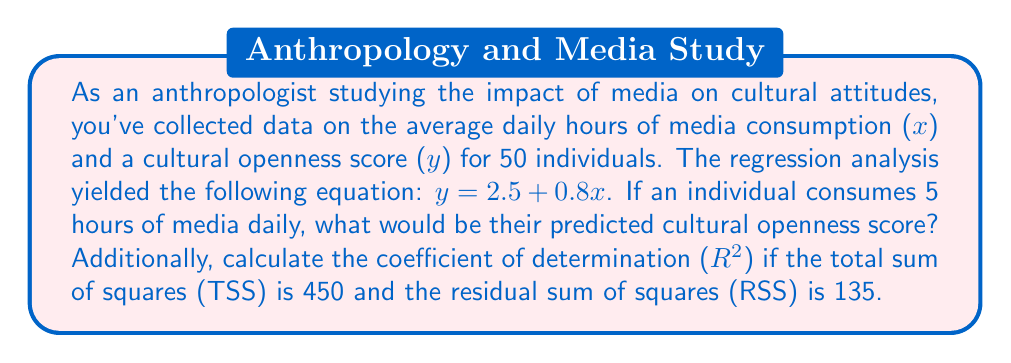Teach me how to tackle this problem. 1. To find the predicted cultural openness score for 5 hours of media consumption:
   Substitute x = 5 into the regression equation:
   $y = 2.5 + 0.8x$
   $y = 2.5 + 0.8(5)$
   $y = 2.5 + 4$
   $y = 6.5$

2. To calculate the coefficient of determination ($R^2$):
   $R^2 = 1 - \frac{RSS}{TSS}$
   
   Where:
   TSS (Total Sum of Squares) = 450
   RSS (Residual Sum of Squares) = 135

   $R^2 = 1 - \frac{135}{450}$
   $R^2 = 1 - 0.3$
   $R^2 = 0.7$

The $R^2$ value of 0.7 indicates that 70% of the variability in cultural openness scores can be explained by media consumption in this model.
Answer: Predicted cultural openness score: 6.5; $R^2 = 0.7$ 